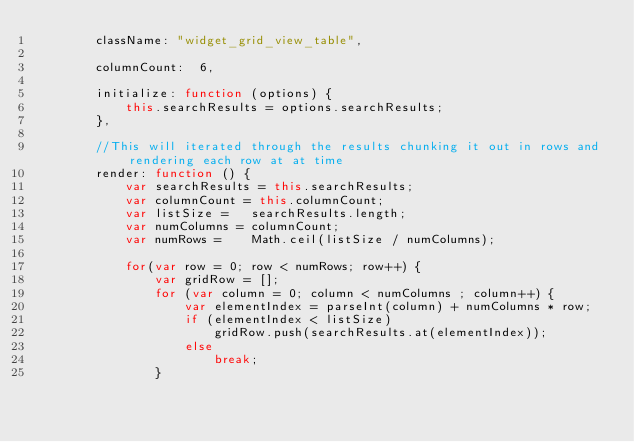Convert code to text. <code><loc_0><loc_0><loc_500><loc_500><_JavaScript_>        className: "widget_grid_view_table",
        
        columnCount:  6,
        
        initialize: function (options) {
            this.searchResults = options.searchResults;
        },      
        
        //This will iterated through the results chunking it out in rows and rendering each row at at time
        render: function () {
            var searchResults = this.searchResults;
            var columnCount = this.columnCount;
            var listSize =   searchResults.length;
            var numColumns = columnCount;
            var numRows =    Math.ceil(listSize / numColumns);

            for(var row = 0; row < numRows; row++) {
                var gridRow = [];
                for (var column = 0; column < numColumns ; column++) {
                    var elementIndex = parseInt(column) + numColumns * row;
                    if (elementIndex < listSize)
                        gridRow.push(searchResults.at(elementIndex));
                    else
                        break;
                }</code> 